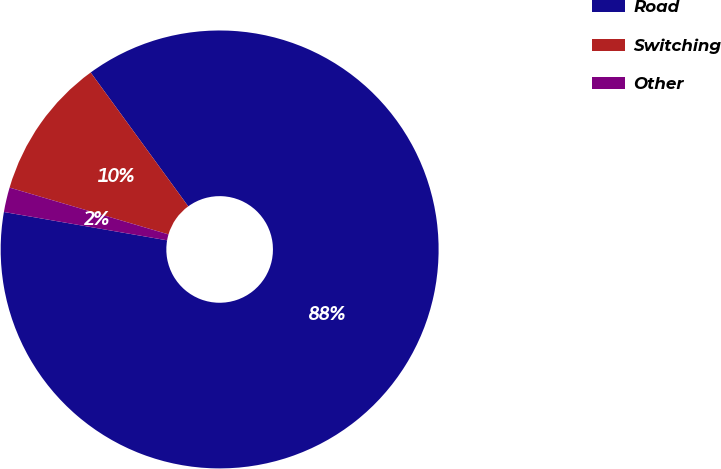Convert chart to OTSL. <chart><loc_0><loc_0><loc_500><loc_500><pie_chart><fcel>Road<fcel>Switching<fcel>Other<nl><fcel>87.76%<fcel>10.42%<fcel>1.82%<nl></chart> 